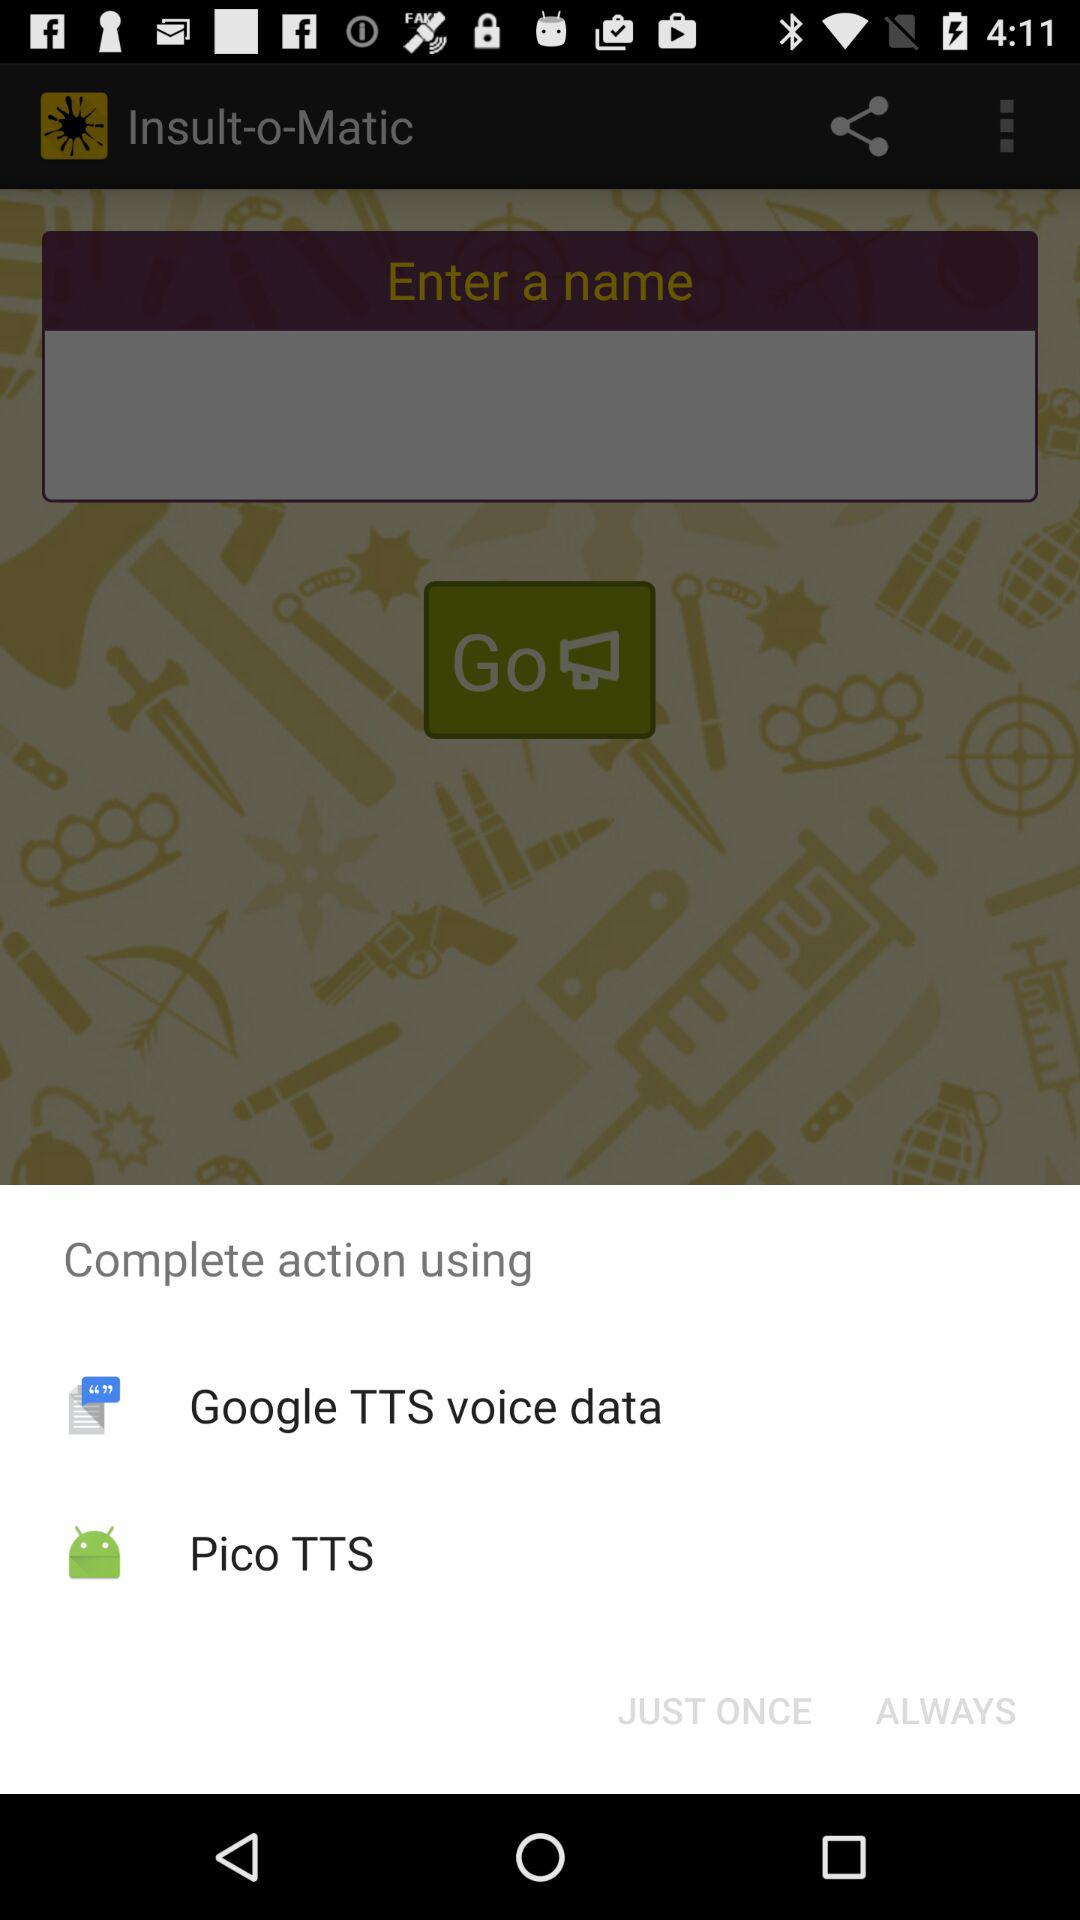What is the entered name?
When the provided information is insufficient, respond with <no answer>. <no answer> 